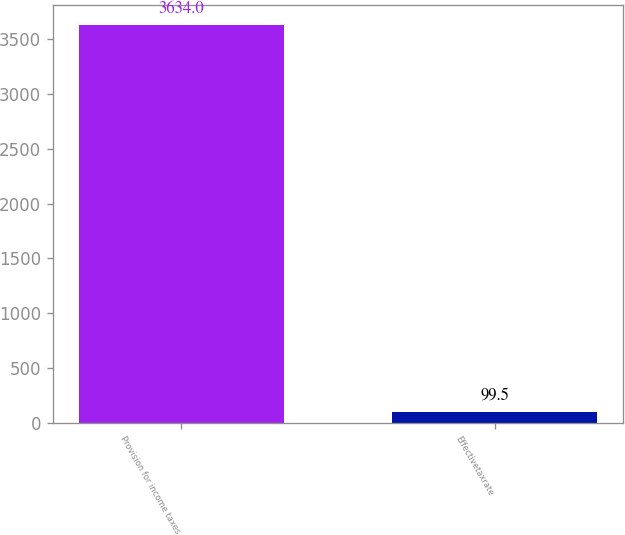Convert chart. <chart><loc_0><loc_0><loc_500><loc_500><bar_chart><fcel>Provision for income taxes<fcel>Effectivetaxrate<nl><fcel>3634<fcel>99.5<nl></chart> 